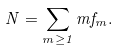<formula> <loc_0><loc_0><loc_500><loc_500>N = \sum _ { m \geq 1 } m f _ { m } .</formula> 